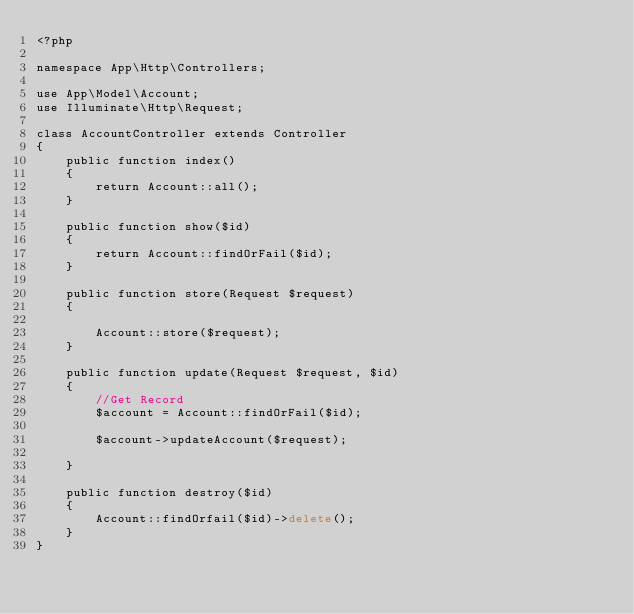Convert code to text. <code><loc_0><loc_0><loc_500><loc_500><_PHP_><?php

namespace App\Http\Controllers;

use App\Model\Account;
use Illuminate\Http\Request;

class AccountController extends Controller
{
    public function index()
    {
        return Account::all();
    }

    public function show($id)
    {
        return Account::findOrFail($id);
    }

    public function store(Request $request)
    {

        Account::store($request);
    }

    public function update(Request $request, $id)
    {
        //Get Record
        $account = Account::findOrFail($id);

        $account->updateAccount($request);

    }

    public function destroy($id)
    {
        Account::findOrfail($id)->delete();
    }
}
</code> 